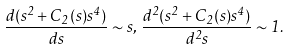Convert formula to latex. <formula><loc_0><loc_0><loc_500><loc_500>\frac { d ( s ^ { 2 } + C _ { 2 } ( s ) s ^ { 4 } ) } { d s } \sim s , \, \frac { d ^ { 2 } ( s ^ { 2 } + C _ { 2 } ( s ) s ^ { 4 } ) } { d ^ { 2 } s } \sim 1 .</formula> 